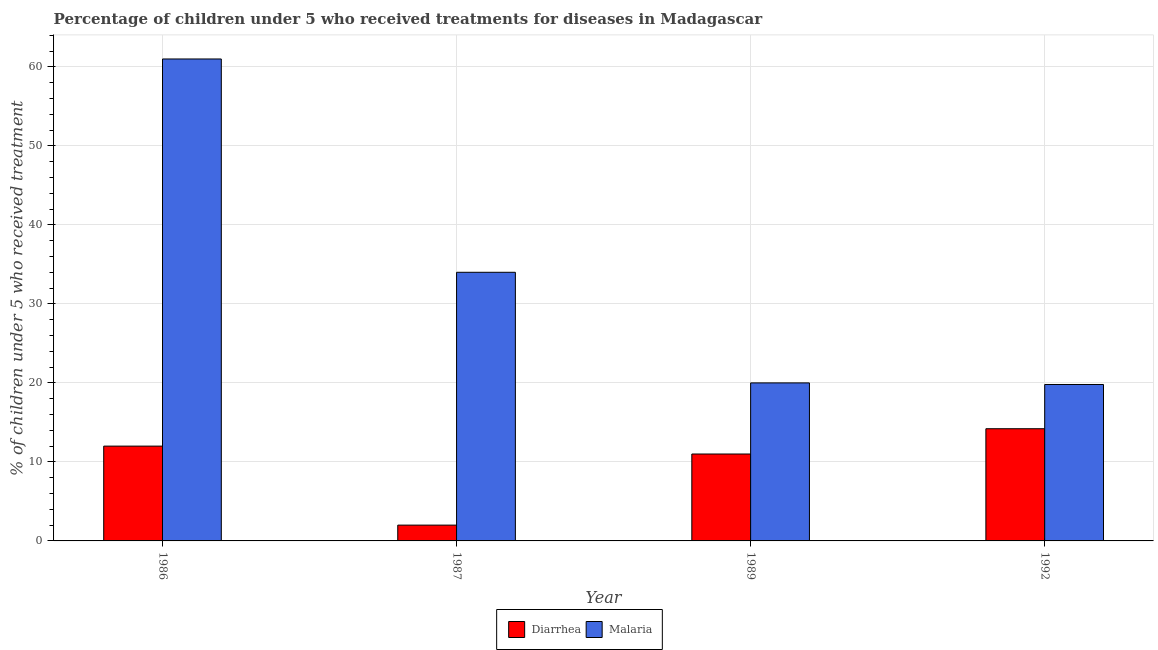How many different coloured bars are there?
Ensure brevity in your answer.  2. How many groups of bars are there?
Ensure brevity in your answer.  4. Are the number of bars per tick equal to the number of legend labels?
Ensure brevity in your answer.  Yes. How many bars are there on the 4th tick from the left?
Your answer should be compact. 2. How many bars are there on the 1st tick from the right?
Offer a terse response. 2. What is the percentage of children who received treatment for diarrhoea in 1992?
Provide a short and direct response. 14.2. Across all years, what is the maximum percentage of children who received treatment for malaria?
Your response must be concise. 61. Across all years, what is the minimum percentage of children who received treatment for malaria?
Give a very brief answer. 19.8. In which year was the percentage of children who received treatment for malaria minimum?
Keep it short and to the point. 1992. What is the total percentage of children who received treatment for diarrhoea in the graph?
Provide a short and direct response. 39.2. What is the difference between the percentage of children who received treatment for malaria in 1986 and that in 1992?
Your answer should be compact. 41.2. What is the difference between the percentage of children who received treatment for diarrhoea in 1992 and the percentage of children who received treatment for malaria in 1989?
Your answer should be compact. 3.2. What is the average percentage of children who received treatment for malaria per year?
Provide a succinct answer. 33.7. In the year 1987, what is the difference between the percentage of children who received treatment for diarrhoea and percentage of children who received treatment for malaria?
Your answer should be compact. 0. In how many years, is the percentage of children who received treatment for diarrhoea greater than 34 %?
Keep it short and to the point. 0. What is the ratio of the percentage of children who received treatment for diarrhoea in 1989 to that in 1992?
Your response must be concise. 0.77. Is the percentage of children who received treatment for diarrhoea in 1989 less than that in 1992?
Make the answer very short. Yes. What is the difference between the highest and the second highest percentage of children who received treatment for diarrhoea?
Provide a succinct answer. 2.2. Is the sum of the percentage of children who received treatment for malaria in 1989 and 1992 greater than the maximum percentage of children who received treatment for diarrhoea across all years?
Your answer should be compact. No. What does the 2nd bar from the left in 1987 represents?
Give a very brief answer. Malaria. What does the 2nd bar from the right in 1986 represents?
Give a very brief answer. Diarrhea. How many bars are there?
Give a very brief answer. 8. Are all the bars in the graph horizontal?
Keep it short and to the point. No. What is the difference between two consecutive major ticks on the Y-axis?
Your answer should be very brief. 10. Does the graph contain grids?
Your response must be concise. Yes. Where does the legend appear in the graph?
Your answer should be very brief. Bottom center. How many legend labels are there?
Offer a very short reply. 2. How are the legend labels stacked?
Provide a succinct answer. Horizontal. What is the title of the graph?
Keep it short and to the point. Percentage of children under 5 who received treatments for diseases in Madagascar. Does "Secondary education" appear as one of the legend labels in the graph?
Offer a very short reply. No. What is the label or title of the X-axis?
Offer a terse response. Year. What is the label or title of the Y-axis?
Offer a terse response. % of children under 5 who received treatment. What is the % of children under 5 who received treatment in Diarrhea in 1986?
Your answer should be very brief. 12. What is the % of children under 5 who received treatment in Malaria in 1986?
Keep it short and to the point. 61. What is the % of children under 5 who received treatment of Diarrhea in 1987?
Keep it short and to the point. 2. What is the % of children under 5 who received treatment of Malaria in 1987?
Offer a terse response. 34. What is the % of children under 5 who received treatment of Diarrhea in 1989?
Your answer should be very brief. 11. What is the % of children under 5 who received treatment of Malaria in 1989?
Provide a short and direct response. 20. What is the % of children under 5 who received treatment in Malaria in 1992?
Give a very brief answer. 19.8. Across all years, what is the minimum % of children under 5 who received treatment in Malaria?
Your answer should be very brief. 19.8. What is the total % of children under 5 who received treatment of Diarrhea in the graph?
Provide a short and direct response. 39.2. What is the total % of children under 5 who received treatment of Malaria in the graph?
Offer a very short reply. 134.8. What is the difference between the % of children under 5 who received treatment in Diarrhea in 1986 and that in 1989?
Offer a terse response. 1. What is the difference between the % of children under 5 who received treatment of Malaria in 1986 and that in 1989?
Provide a short and direct response. 41. What is the difference between the % of children under 5 who received treatment in Diarrhea in 1986 and that in 1992?
Make the answer very short. -2.2. What is the difference between the % of children under 5 who received treatment in Malaria in 1986 and that in 1992?
Your response must be concise. 41.2. What is the difference between the % of children under 5 who received treatment in Diarrhea in 1987 and that in 1989?
Provide a succinct answer. -9. What is the difference between the % of children under 5 who received treatment in Diarrhea in 1987 and that in 1992?
Offer a terse response. -12.2. What is the difference between the % of children under 5 who received treatment of Malaria in 1989 and that in 1992?
Provide a succinct answer. 0.2. What is the difference between the % of children under 5 who received treatment of Diarrhea in 1986 and the % of children under 5 who received treatment of Malaria in 1987?
Ensure brevity in your answer.  -22. What is the difference between the % of children under 5 who received treatment of Diarrhea in 1986 and the % of children under 5 who received treatment of Malaria in 1989?
Your response must be concise. -8. What is the difference between the % of children under 5 who received treatment in Diarrhea in 1987 and the % of children under 5 who received treatment in Malaria in 1989?
Give a very brief answer. -18. What is the difference between the % of children under 5 who received treatment of Diarrhea in 1987 and the % of children under 5 who received treatment of Malaria in 1992?
Your answer should be compact. -17.8. What is the difference between the % of children under 5 who received treatment of Diarrhea in 1989 and the % of children under 5 who received treatment of Malaria in 1992?
Offer a very short reply. -8.8. What is the average % of children under 5 who received treatment of Malaria per year?
Your answer should be compact. 33.7. In the year 1986, what is the difference between the % of children under 5 who received treatment of Diarrhea and % of children under 5 who received treatment of Malaria?
Your answer should be very brief. -49. In the year 1987, what is the difference between the % of children under 5 who received treatment in Diarrhea and % of children under 5 who received treatment in Malaria?
Your answer should be very brief. -32. In the year 1992, what is the difference between the % of children under 5 who received treatment of Diarrhea and % of children under 5 who received treatment of Malaria?
Give a very brief answer. -5.6. What is the ratio of the % of children under 5 who received treatment in Malaria in 1986 to that in 1987?
Provide a short and direct response. 1.79. What is the ratio of the % of children under 5 who received treatment in Malaria in 1986 to that in 1989?
Offer a terse response. 3.05. What is the ratio of the % of children under 5 who received treatment of Diarrhea in 1986 to that in 1992?
Make the answer very short. 0.85. What is the ratio of the % of children under 5 who received treatment of Malaria in 1986 to that in 1992?
Provide a succinct answer. 3.08. What is the ratio of the % of children under 5 who received treatment of Diarrhea in 1987 to that in 1989?
Provide a short and direct response. 0.18. What is the ratio of the % of children under 5 who received treatment of Malaria in 1987 to that in 1989?
Ensure brevity in your answer.  1.7. What is the ratio of the % of children under 5 who received treatment in Diarrhea in 1987 to that in 1992?
Offer a terse response. 0.14. What is the ratio of the % of children under 5 who received treatment of Malaria in 1987 to that in 1992?
Give a very brief answer. 1.72. What is the ratio of the % of children under 5 who received treatment of Diarrhea in 1989 to that in 1992?
Provide a short and direct response. 0.77. What is the difference between the highest and the second highest % of children under 5 who received treatment of Diarrhea?
Offer a very short reply. 2.2. What is the difference between the highest and the lowest % of children under 5 who received treatment in Malaria?
Keep it short and to the point. 41.2. 